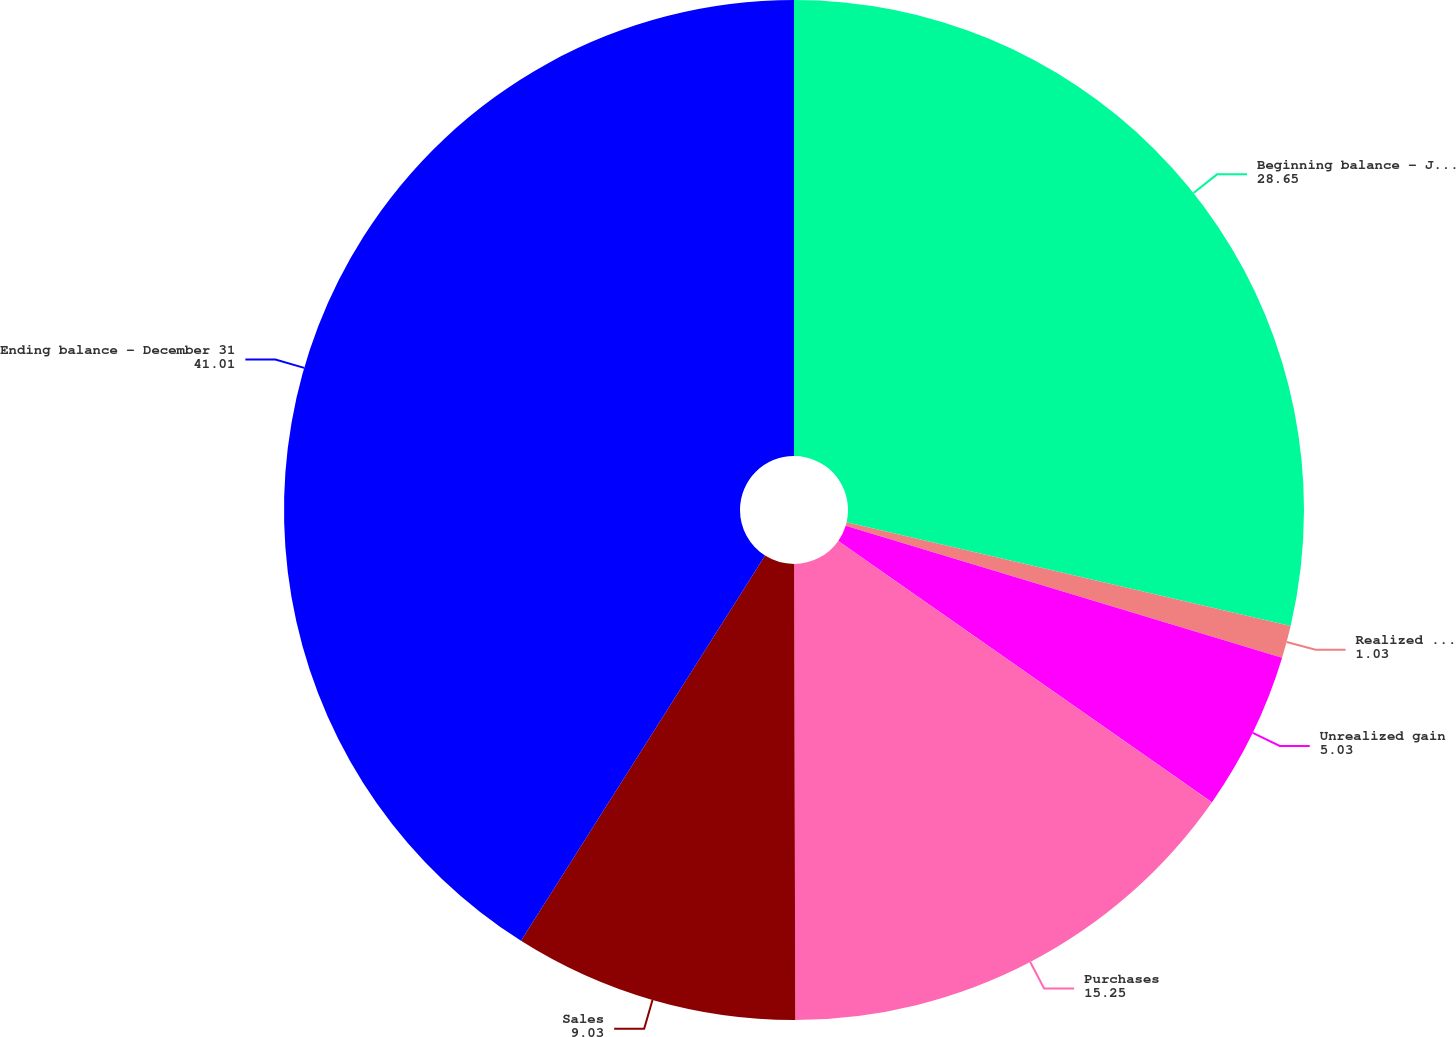<chart> <loc_0><loc_0><loc_500><loc_500><pie_chart><fcel>Beginning balance - January 1<fcel>Realized gain<fcel>Unrealized gain<fcel>Purchases<fcel>Sales<fcel>Ending balance - December 31<nl><fcel>28.65%<fcel>1.03%<fcel>5.03%<fcel>15.25%<fcel>9.03%<fcel>41.01%<nl></chart> 